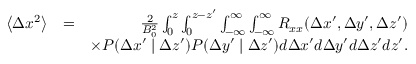<formula> <loc_0><loc_0><loc_500><loc_500>\begin{array} { r l r } { \left \langle \Delta x ^ { 2 } \right \rangle } & { = } & { \frac { 2 } { B _ { 0 } ^ { 2 } } \int _ { 0 } ^ { z } \int _ { 0 } ^ { z - { z } ^ { \prime } } \int _ { - \infty } ^ { \infty } \int _ { - \infty } ^ { \infty } R _ { x x } ( \Delta x ^ { \prime } , \Delta y ^ { \prime } , \Delta z ^ { \prime } ) } \\ & { \times P ( \Delta x ^ { \prime } | \Delta z ^ { \prime } ) P ( \Delta y ^ { \prime } | \Delta z ^ { \prime } ) d \Delta x ^ { \prime } d \Delta y ^ { \prime } d \Delta z ^ { \prime } d { z } ^ { \prime } . } \end{array}</formula> 